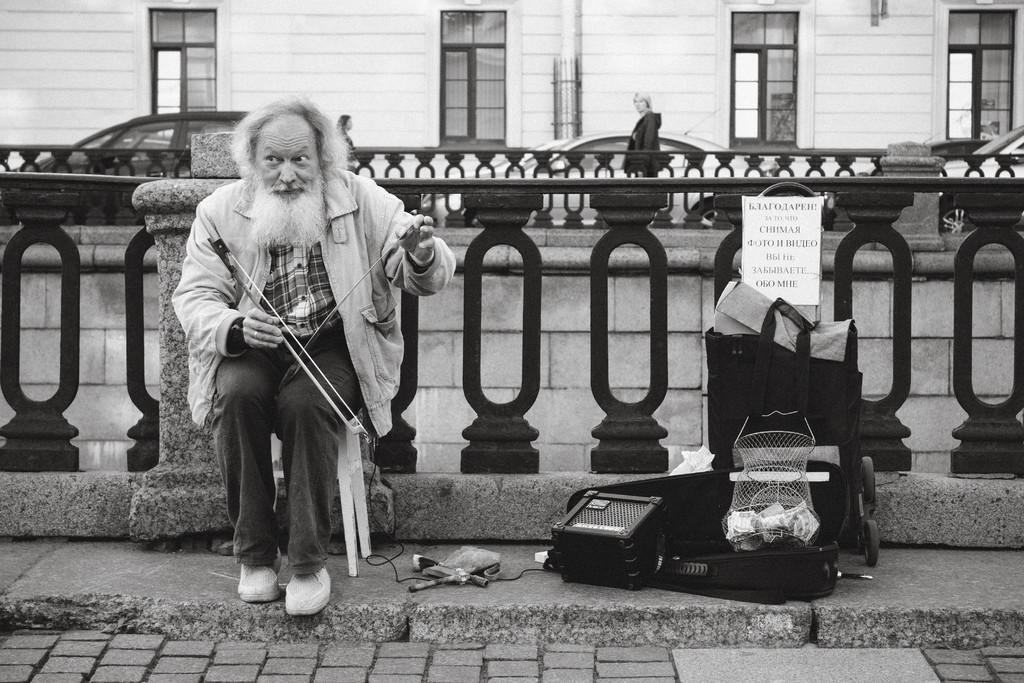Please provide a concise description of this image. There is a person sitting on chair and playing musical instrument near a pole and fencing. On the right side, there is a board which is on the bag, there is a speaker and other objects on the footpath. In the background, there is a person standing on the footpath, there are vehicles on the road and there is a white color building which is having glass windows. 